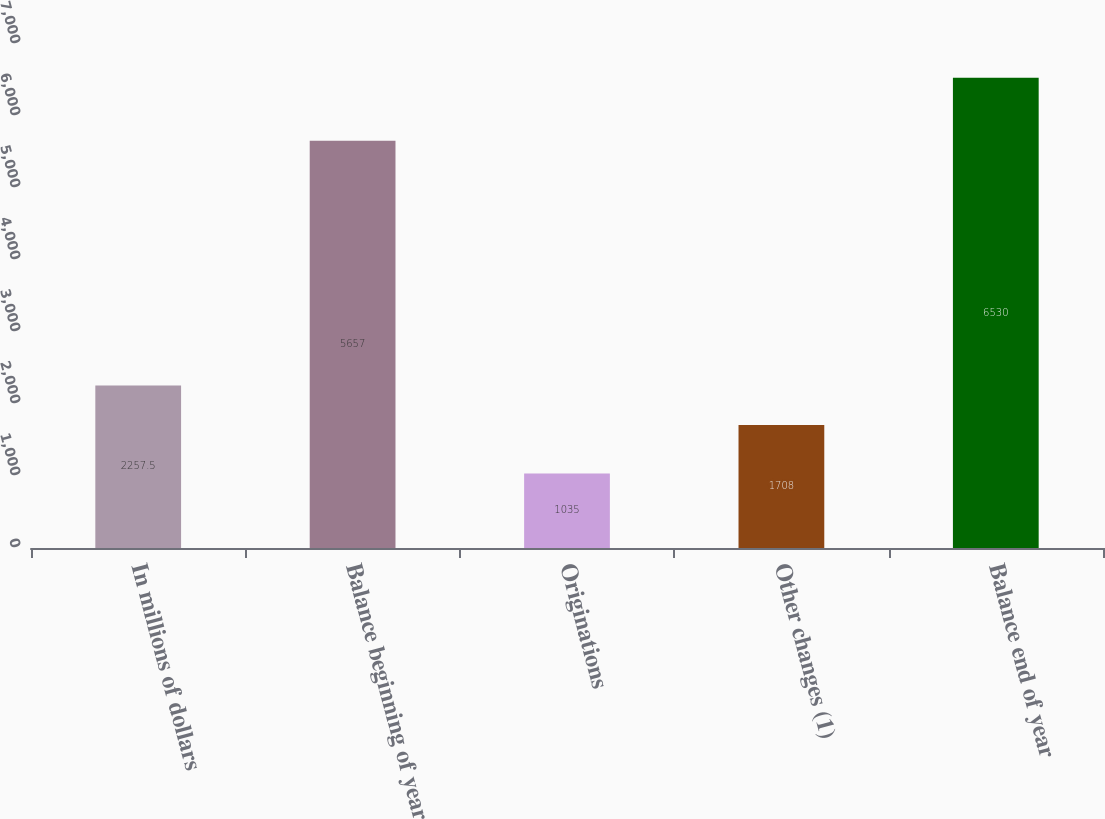Convert chart. <chart><loc_0><loc_0><loc_500><loc_500><bar_chart><fcel>In millions of dollars<fcel>Balance beginning of year<fcel>Originations<fcel>Other changes (1)<fcel>Balance end of year<nl><fcel>2257.5<fcel>5657<fcel>1035<fcel>1708<fcel>6530<nl></chart> 